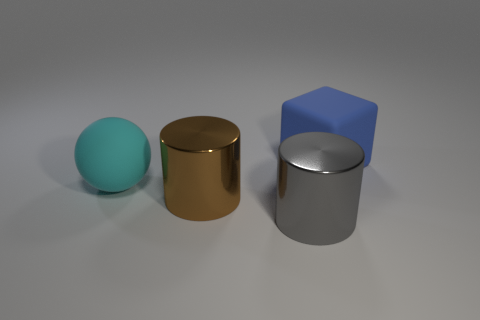What is the large cyan object made of?
Offer a very short reply. Rubber. What is the color of the cylinder in front of the brown cylinder?
Keep it short and to the point. Gray. Is the number of objects that are behind the brown metallic cylinder greater than the number of large brown metallic cylinders that are behind the cyan thing?
Give a very brief answer. Yes. What is the size of the rubber thing that is in front of the matte thing that is right of the big rubber object that is in front of the blue thing?
Offer a very short reply. Large. What number of brown cylinders are there?
Your response must be concise. 1. What material is the thing on the right side of the big gray metal object that is on the right side of the big ball behind the big gray shiny cylinder made of?
Provide a short and direct response. Rubber. Are there any large gray objects that have the same material as the blue block?
Offer a terse response. No. Does the large gray thing have the same material as the brown cylinder?
Make the answer very short. Yes. What number of cylinders are either large metal things or gray things?
Provide a short and direct response. 2. What is the color of the thing that is the same material as the cube?
Provide a succinct answer. Cyan. 